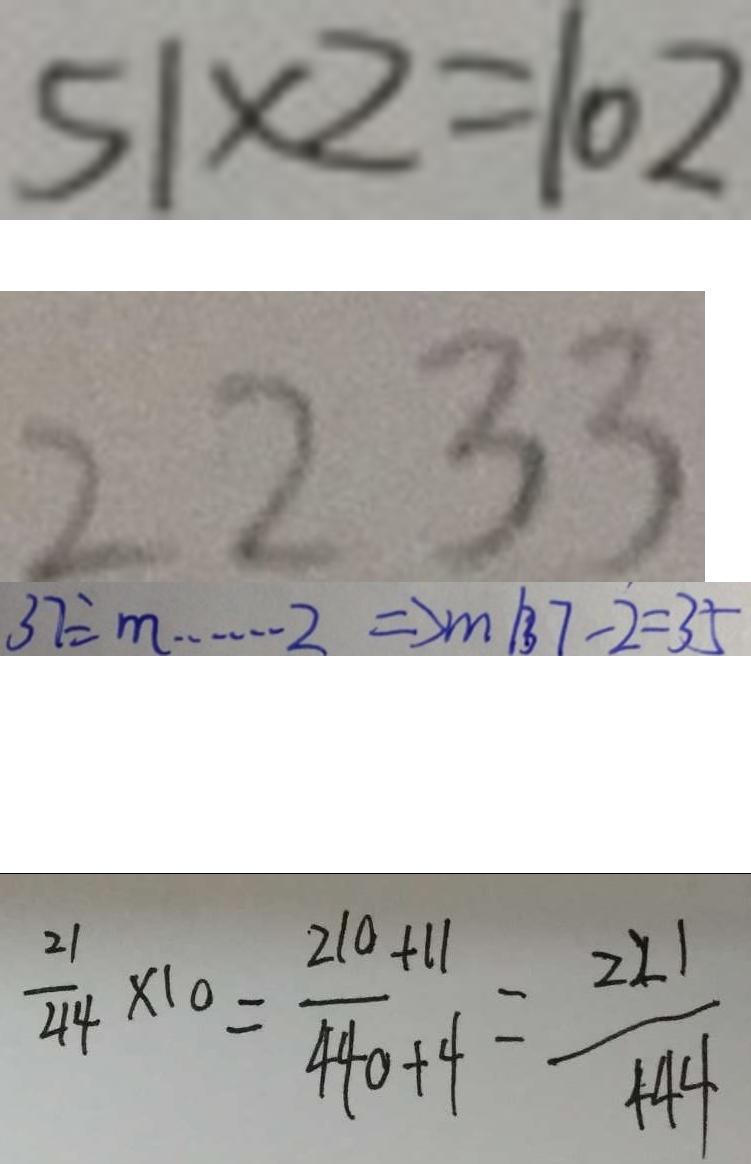<formula> <loc_0><loc_0><loc_500><loc_500>5 1 \times 2 = 1 0 2 
 2 2 3 3 
 3 7 \div \cdots 2 \Rightarrow m \vert 3 7 - 2 = 3 5 
 \frac { 2 1 } { 4 4 } \times 1 0 = \frac { 2 1 0 + 1 1 } { 4 4 0 + 4 } = \frac { 2 2 1 } { 4 4 4 }</formula> 